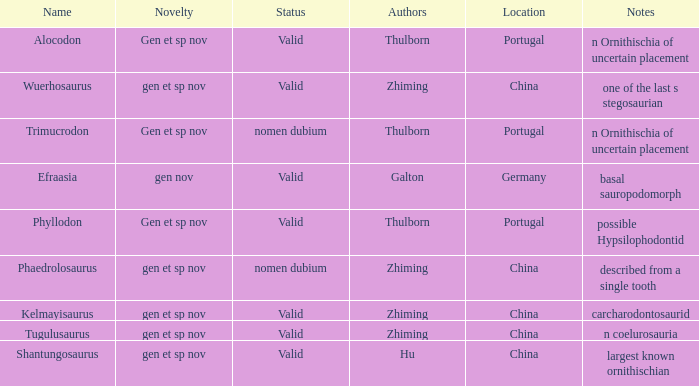What is the Name of the dinosaur that was discovered in the Location, China, and whose Notes are, "described from a single tooth"? Phaedrolosaurus. 